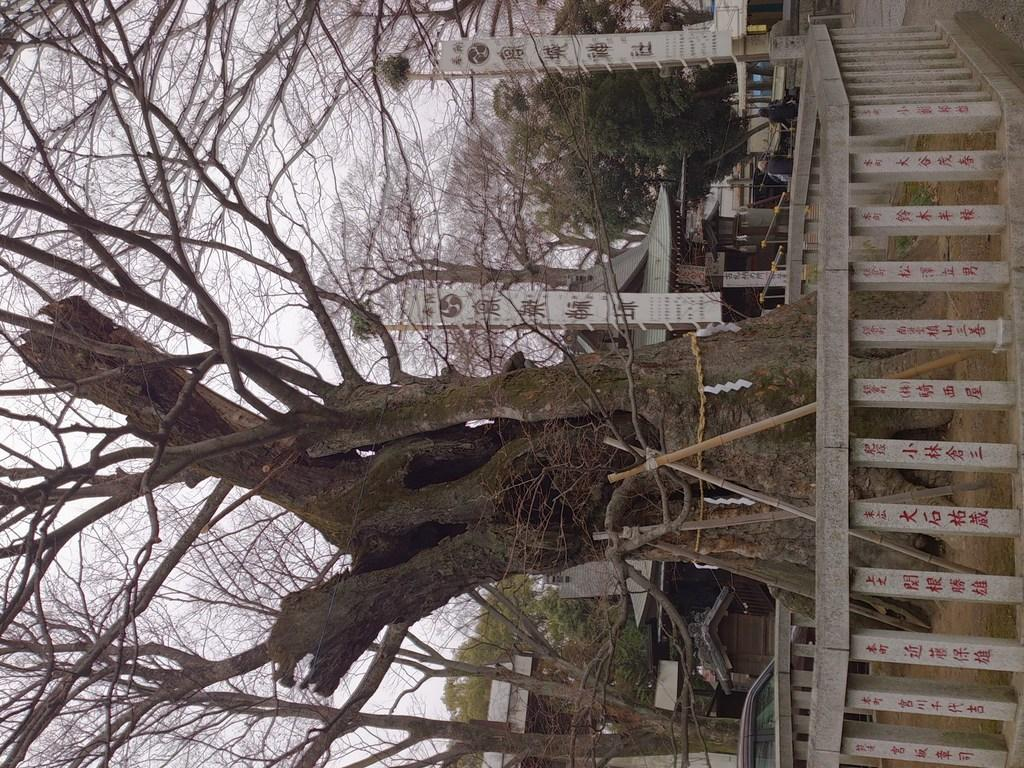What is surrounding the tree in the image? There is a wooden railing around the tree in the image. What is the color of the tree? The tree is brown in color. What can be seen in the background of the image? There are buildings and trees in the background of the image. What part of the natural environment is visible in the image? The sky is visible in the background of the image. What type of pollution is visible in the image? There is no visible pollution in the image. What is the tree afraid of in the image? Trees do not experience fear, so there is no indication of fear in the image. 